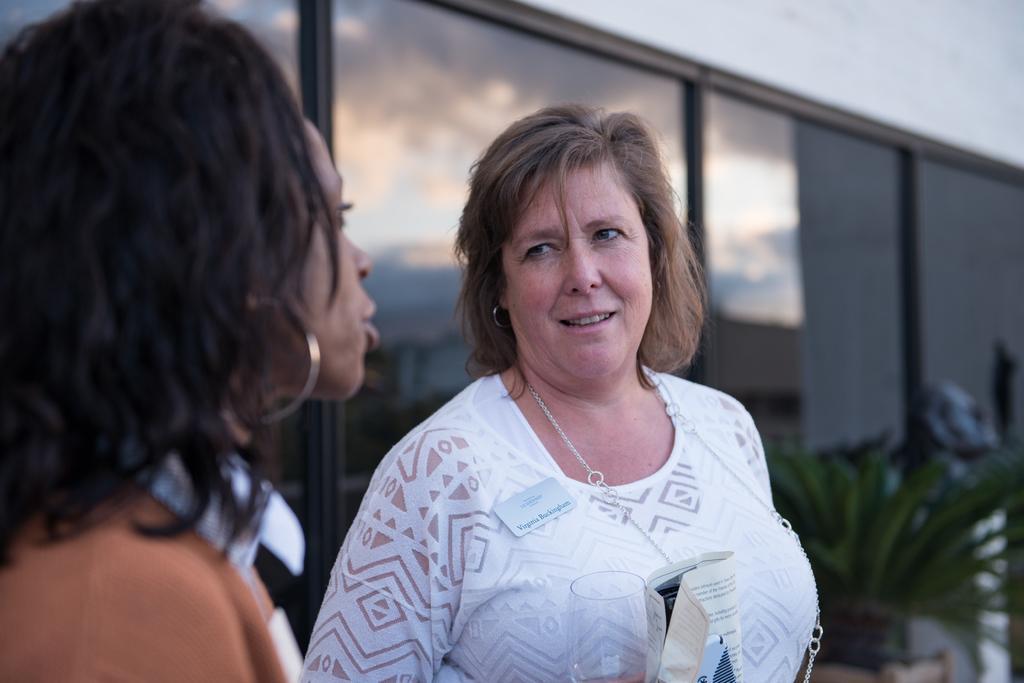In one or two sentences, can you explain what this image depicts? In this image we can see two women. We can also see a woman holding the glass and the paper. In the background we can also see the glass windows and also the plant. 